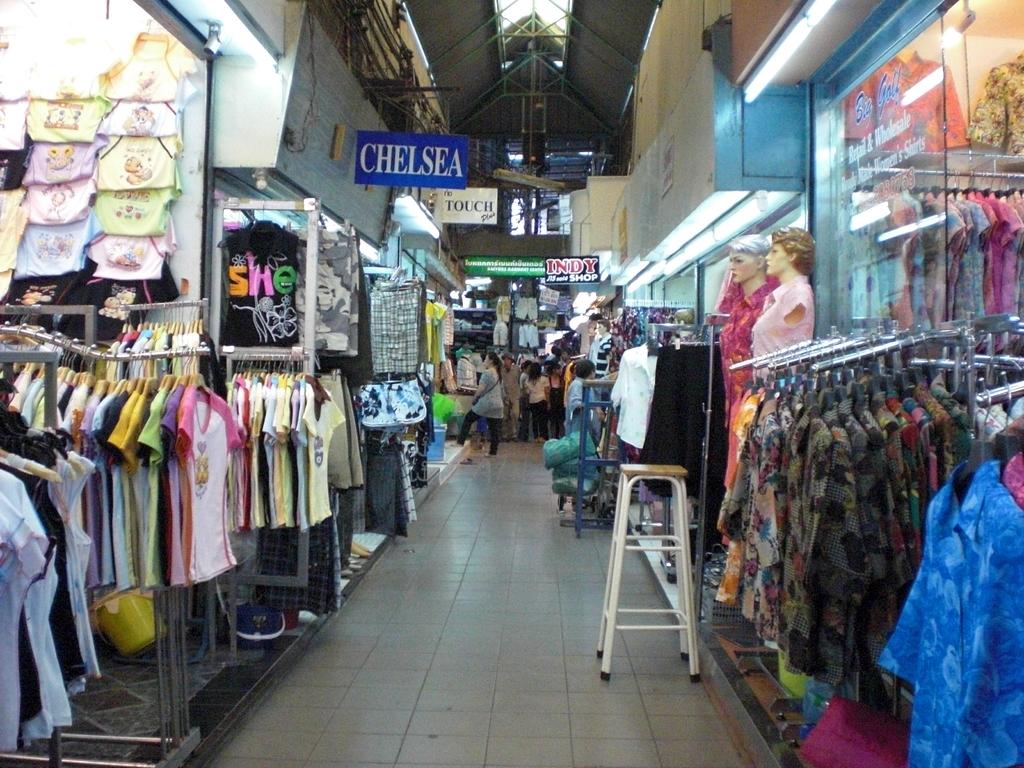What is the name of the store?
Make the answer very short. Chelsea. 